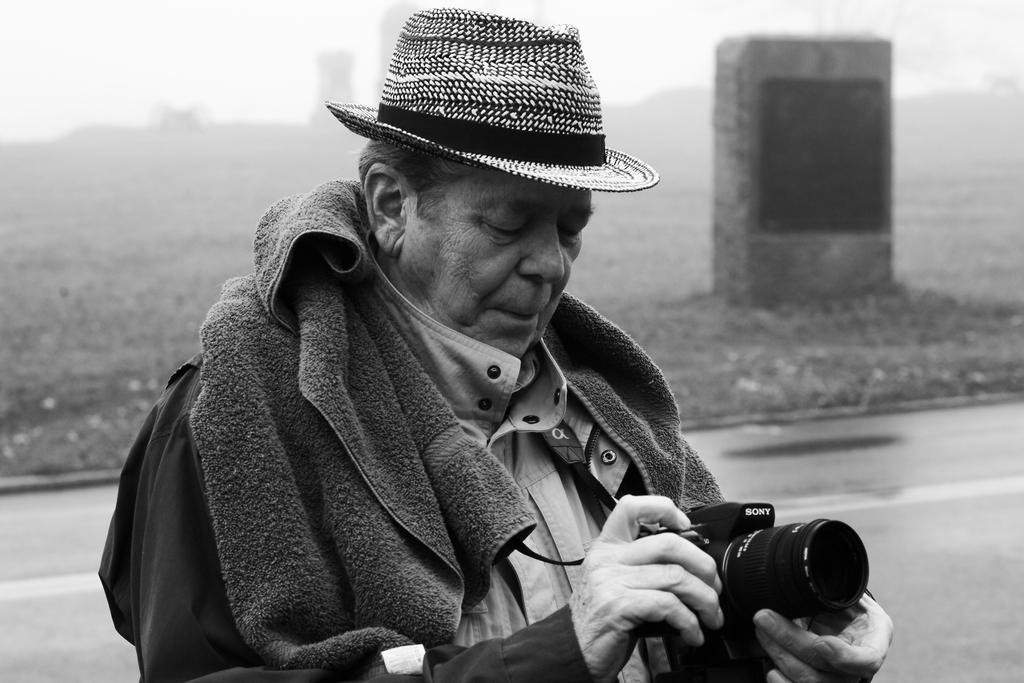How would you summarize this image in a sentence or two? In this picture we can see man wore cap, towel on his neck holding camera in his hand and looking at it and in background we can see stone, land, buildings, smoke, road. 